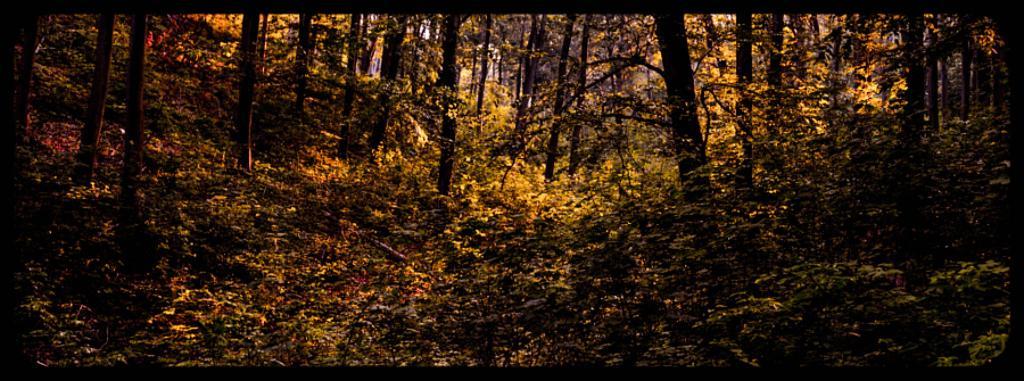Could you give a brief overview of what you see in this image? In the picture I can see trees, plants, the grass and some other objects on the ground. 